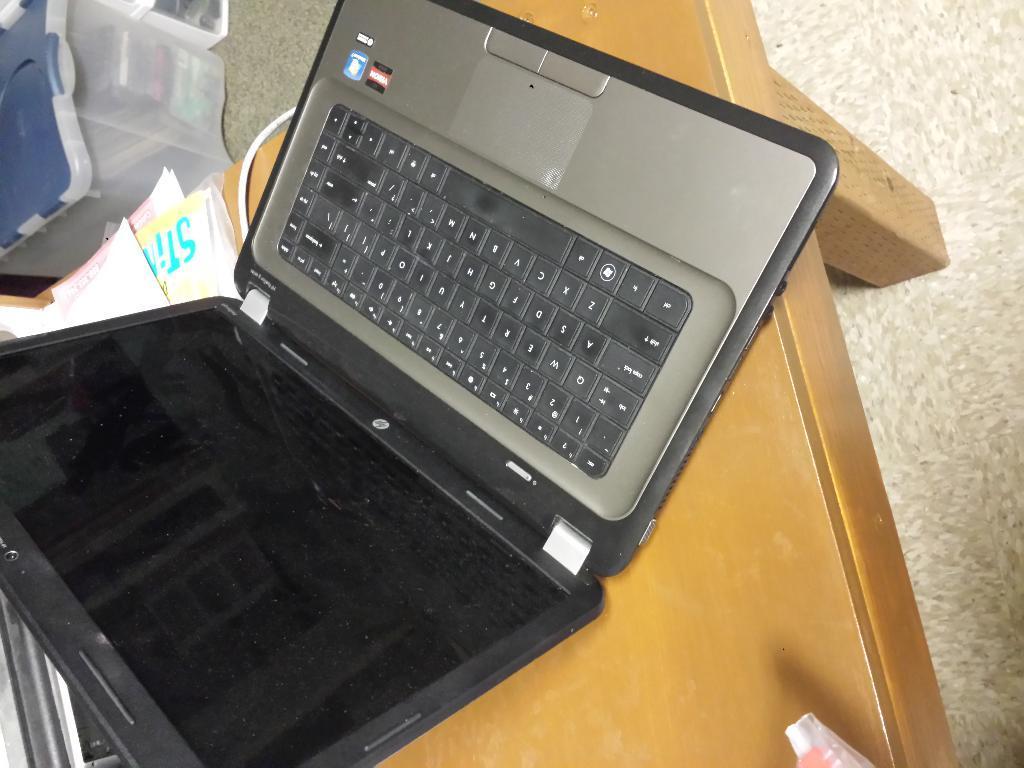Please provide a concise description of this image. We can see laptop and objects on the table and we can see box on the floor. 